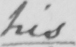What does this handwritten line say? his 